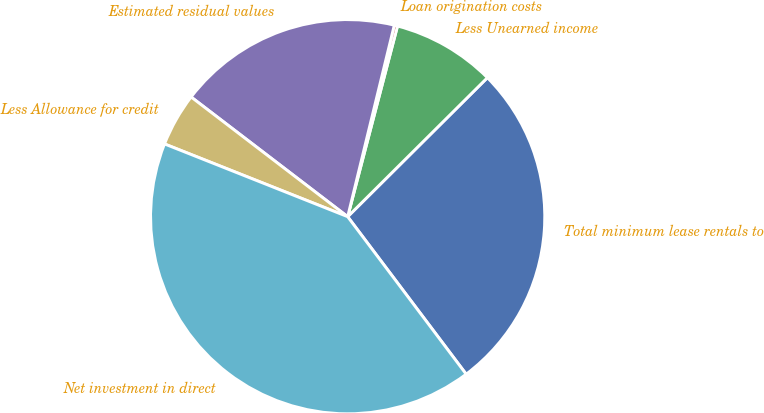Convert chart to OTSL. <chart><loc_0><loc_0><loc_500><loc_500><pie_chart><fcel>Total minimum lease rentals to<fcel>Less Unearned income<fcel>Loan origination costs<fcel>Estimated residual values<fcel>Less Allowance for credit<fcel>Net investment in direct<nl><fcel>27.19%<fcel>8.47%<fcel>0.27%<fcel>18.41%<fcel>4.37%<fcel>41.28%<nl></chart> 